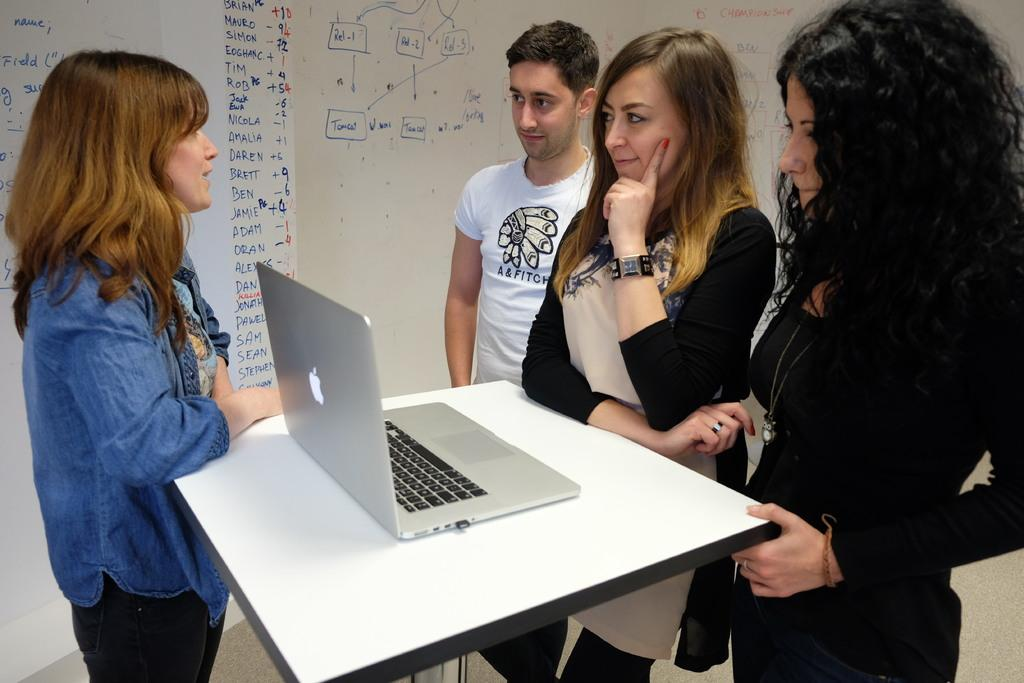How many people are in the image? There are four persons in the image. What are the people doing in the image? The persons are standing around a table. What object can be seen on the table? There is a laptop on the table. What is the color of the board in the image? There is a white color board in the image. How does the street feel in the image? There is no street present in the image, so it is not possible to determine how it might feel. 